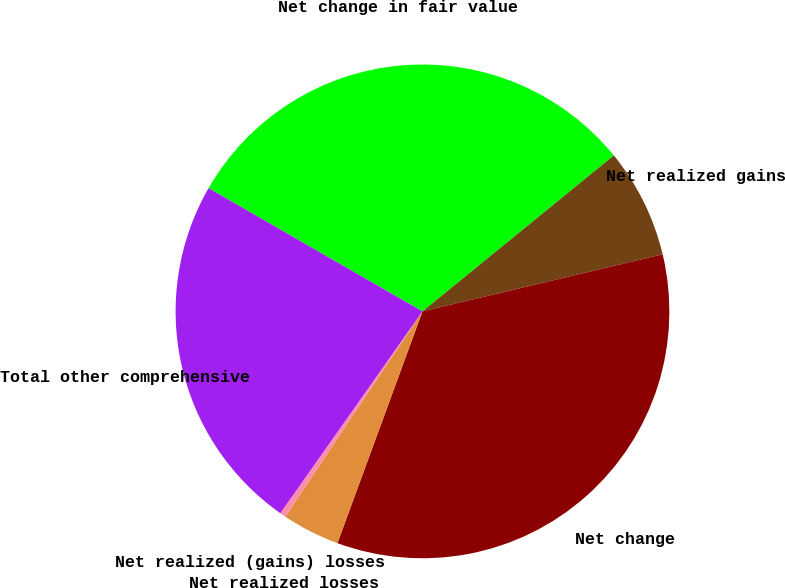<chart> <loc_0><loc_0><loc_500><loc_500><pie_chart><fcel>Net change in fair value<fcel>Net realized gains<fcel>Net change<fcel>Net realized losses<fcel>Net realized (gains) losses<fcel>Total other comprehensive<nl><fcel>30.8%<fcel>7.17%<fcel>34.31%<fcel>3.78%<fcel>0.39%<fcel>23.55%<nl></chart> 